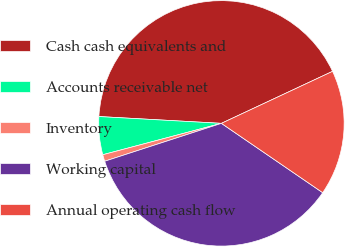<chart> <loc_0><loc_0><loc_500><loc_500><pie_chart><fcel>Cash cash equivalents and<fcel>Accounts receivable net<fcel>Inventory<fcel>Working capital<fcel>Annual operating cash flow<nl><fcel>42.15%<fcel>5.0%<fcel>0.88%<fcel>35.45%<fcel>16.52%<nl></chart> 